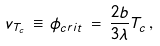Convert formula to latex. <formula><loc_0><loc_0><loc_500><loc_500>v _ { T _ { c } } \, \equiv \, \phi _ { c r i t } \, = \, \frac { 2 b } { 3 \lambda } T _ { c } \, ,</formula> 